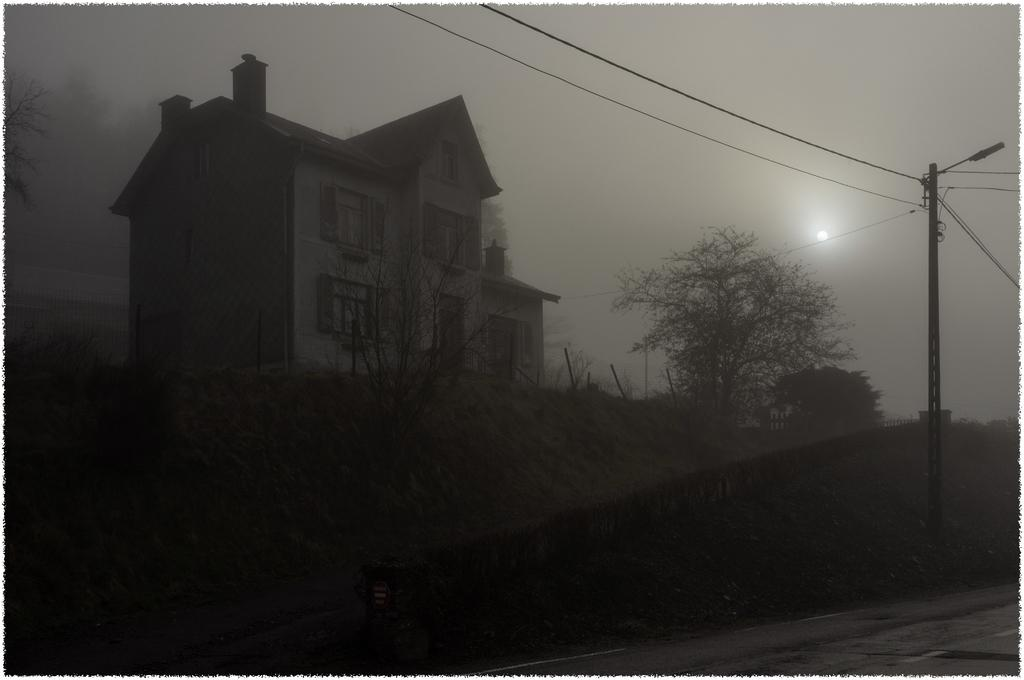What is the main structure in the image? There is a building in the image. What type of natural elements are present around the building? There are trees around the building. What can be seen on the right side of the image? There is a current pole with wires on the right side of the image. What type of engine is powering the pail in the image? There is no pail or engine present in the image. What scale is used to measure the height of the trees in the image? There is no scale present in the image to measure the height of the trees. 